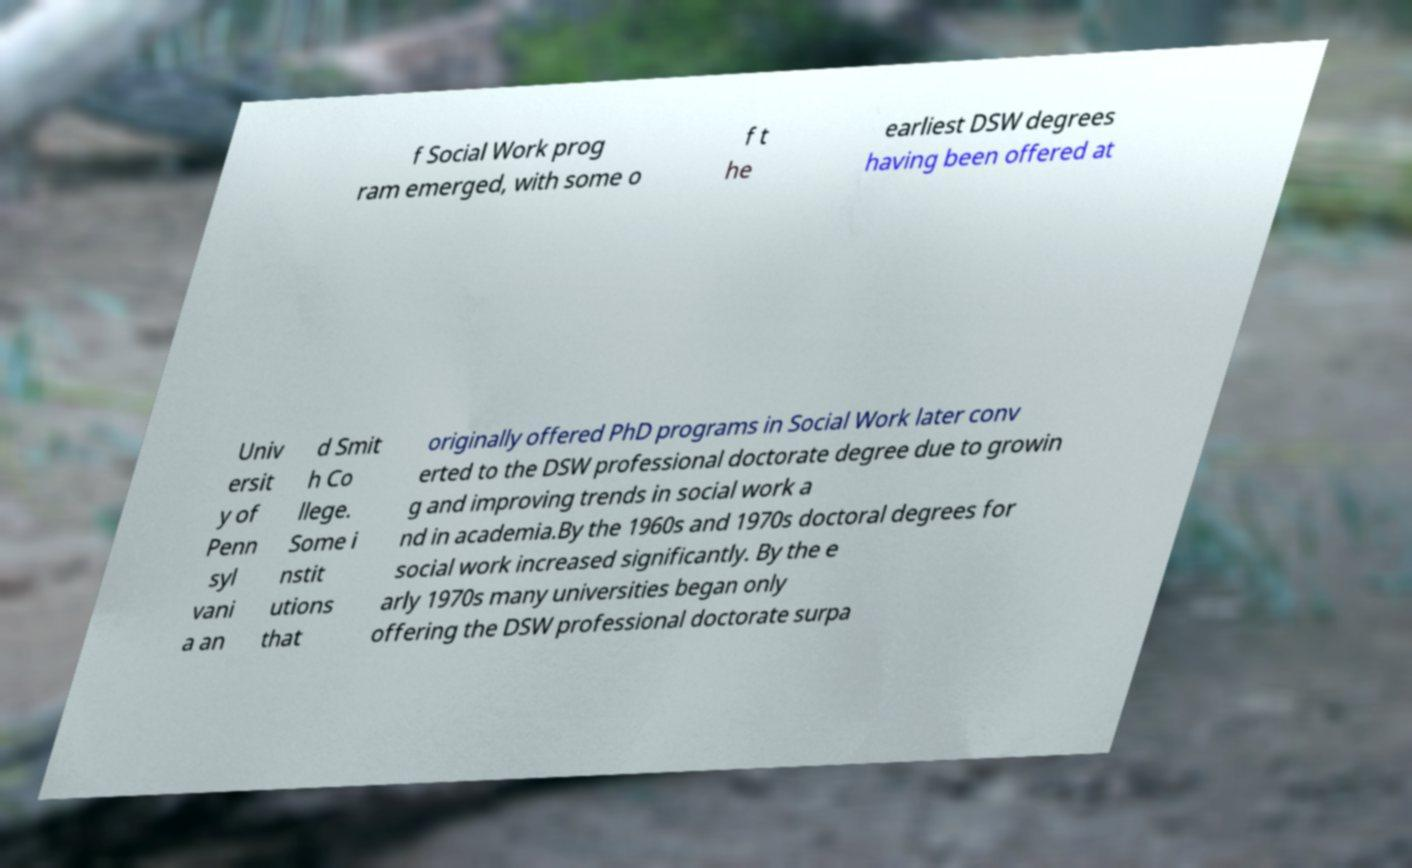Could you extract and type out the text from this image? f Social Work prog ram emerged, with some o f t he earliest DSW degrees having been offered at Univ ersit y of Penn syl vani a an d Smit h Co llege. Some i nstit utions that originally offered PhD programs in Social Work later conv erted to the DSW professional doctorate degree due to growin g and improving trends in social work a nd in academia.By the 1960s and 1970s doctoral degrees for social work increased significantly. By the e arly 1970s many universities began only offering the DSW professional doctorate surpa 